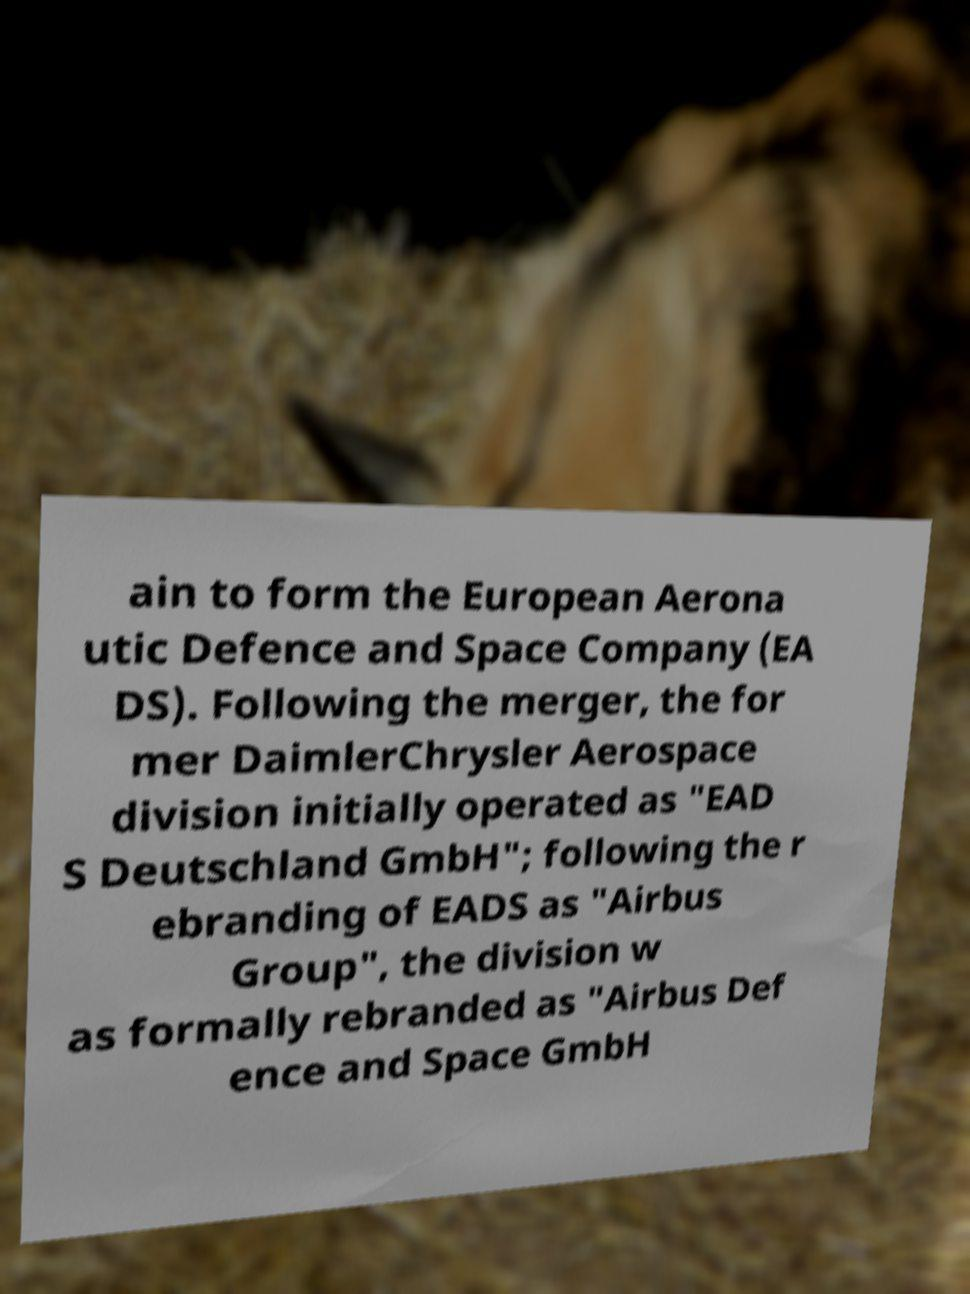I need the written content from this picture converted into text. Can you do that? ain to form the European Aerona utic Defence and Space Company (EA DS). Following the merger, the for mer DaimlerChrysler Aerospace division initially operated as "EAD S Deutschland GmbH"; following the r ebranding of EADS as "Airbus Group", the division w as formally rebranded as "Airbus Def ence and Space GmbH 